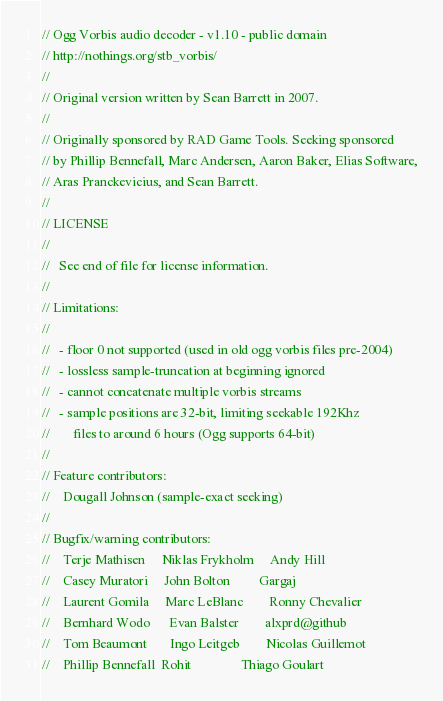Convert code to text. <code><loc_0><loc_0><loc_500><loc_500><_C_>// Ogg Vorbis audio decoder - v1.10 - public domain
// http://nothings.org/stb_vorbis/
//
// Original version written by Sean Barrett in 2007.
//
// Originally sponsored by RAD Game Tools. Seeking sponsored
// by Phillip Bennefall, Marc Andersen, Aaron Baker, Elias Software,
// Aras Pranckevicius, and Sean Barrett.
//
// LICENSE
//
//   See end of file for license information.
//
// Limitations:
//
//   - floor 0 not supported (used in old ogg vorbis files pre-2004)
//   - lossless sample-truncation at beginning ignored
//   - cannot concatenate multiple vorbis streams
//   - sample positions are 32-bit, limiting seekable 192Khz
//       files to around 6 hours (Ogg supports 64-bit)
//
// Feature contributors:
//    Dougall Johnson (sample-exact seeking)
//
// Bugfix/warning contributors:
//    Terje Mathisen     Niklas Frykholm     Andy Hill
//    Casey Muratori     John Bolton         Gargaj
//    Laurent Gomila     Marc LeBlanc        Ronny Chevalier
//    Bernhard Wodo      Evan Balster        alxprd@github
//    Tom Beaumont       Ingo Leitgeb        Nicolas Guillemot
//    Phillip Bennefall  Rohit               Thiago Goulart</code> 